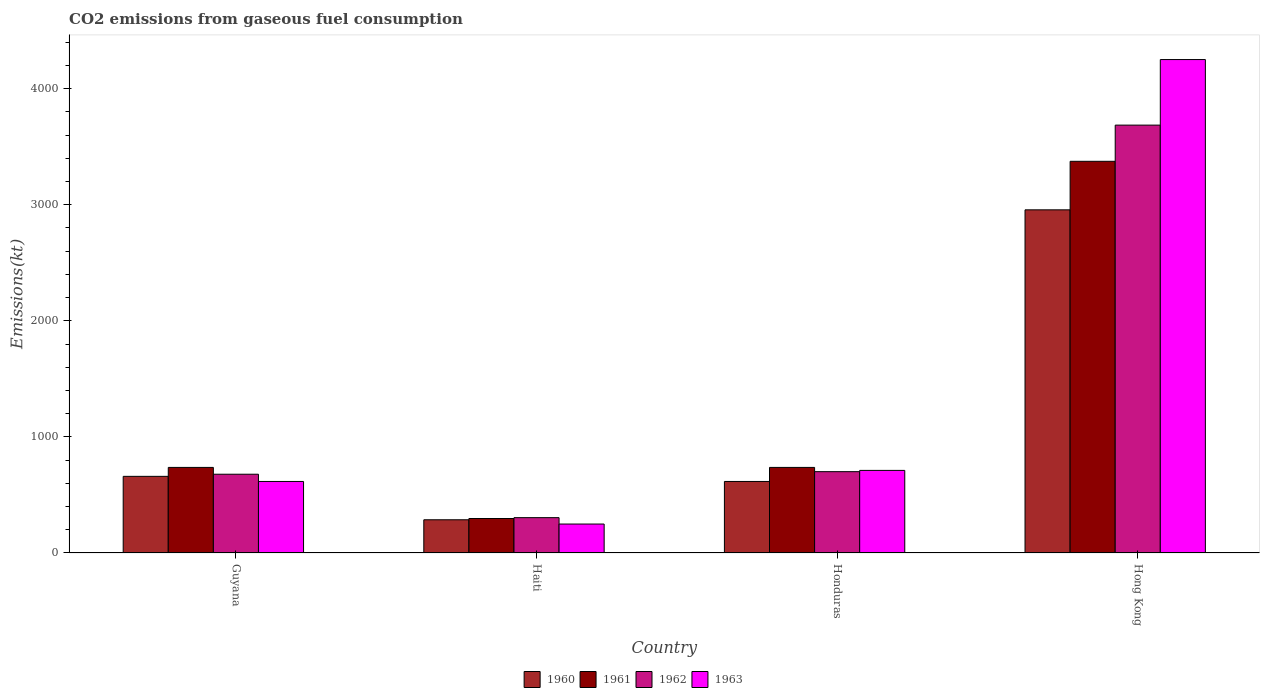Are the number of bars per tick equal to the number of legend labels?
Give a very brief answer. Yes. Are the number of bars on each tick of the X-axis equal?
Ensure brevity in your answer.  Yes. How many bars are there on the 1st tick from the left?
Provide a short and direct response. 4. What is the label of the 2nd group of bars from the left?
Your response must be concise. Haiti. What is the amount of CO2 emitted in 1960 in Haiti?
Give a very brief answer. 286.03. Across all countries, what is the maximum amount of CO2 emitted in 1960?
Provide a short and direct response. 2955.6. Across all countries, what is the minimum amount of CO2 emitted in 1963?
Provide a succinct answer. 249.36. In which country was the amount of CO2 emitted in 1962 maximum?
Offer a very short reply. Hong Kong. In which country was the amount of CO2 emitted in 1963 minimum?
Offer a very short reply. Haiti. What is the total amount of CO2 emitted in 1961 in the graph?
Keep it short and to the point. 5144.8. What is the difference between the amount of CO2 emitted in 1962 in Guyana and that in Honduras?
Your answer should be compact. -22. What is the difference between the amount of CO2 emitted in 1963 in Haiti and the amount of CO2 emitted in 1961 in Hong Kong?
Give a very brief answer. -3124.28. What is the average amount of CO2 emitted in 1963 per country?
Provide a succinct answer. 1456.72. What is the difference between the amount of CO2 emitted of/in 1963 and amount of CO2 emitted of/in 1960 in Hong Kong?
Provide a short and direct response. 1294.45. What is the ratio of the amount of CO2 emitted in 1963 in Haiti to that in Honduras?
Provide a short and direct response. 0.35. What is the difference between the highest and the second highest amount of CO2 emitted in 1960?
Offer a terse response. -2339.55. What is the difference between the highest and the lowest amount of CO2 emitted in 1963?
Ensure brevity in your answer.  4000.7. Is the sum of the amount of CO2 emitted in 1963 in Guyana and Haiti greater than the maximum amount of CO2 emitted in 1960 across all countries?
Provide a succinct answer. No. Is it the case that in every country, the sum of the amount of CO2 emitted in 1960 and amount of CO2 emitted in 1963 is greater than the sum of amount of CO2 emitted in 1961 and amount of CO2 emitted in 1962?
Your answer should be compact. No. How many bars are there?
Ensure brevity in your answer.  16. Are all the bars in the graph horizontal?
Keep it short and to the point. No. Where does the legend appear in the graph?
Offer a terse response. Bottom center. What is the title of the graph?
Make the answer very short. CO2 emissions from gaseous fuel consumption. What is the label or title of the Y-axis?
Your answer should be compact. Emissions(kt). What is the Emissions(kt) in 1960 in Guyana?
Keep it short and to the point. 660.06. What is the Emissions(kt) of 1961 in Guyana?
Provide a short and direct response. 737.07. What is the Emissions(kt) in 1962 in Guyana?
Give a very brief answer. 678.39. What is the Emissions(kt) in 1963 in Guyana?
Your response must be concise. 616.06. What is the Emissions(kt) of 1960 in Haiti?
Give a very brief answer. 286.03. What is the Emissions(kt) of 1961 in Haiti?
Provide a short and direct response. 297.03. What is the Emissions(kt) in 1962 in Haiti?
Make the answer very short. 304.36. What is the Emissions(kt) in 1963 in Haiti?
Give a very brief answer. 249.36. What is the Emissions(kt) of 1960 in Honduras?
Your response must be concise. 616.06. What is the Emissions(kt) in 1961 in Honduras?
Give a very brief answer. 737.07. What is the Emissions(kt) of 1962 in Honduras?
Offer a terse response. 700.4. What is the Emissions(kt) in 1963 in Honduras?
Offer a very short reply. 711.4. What is the Emissions(kt) of 1960 in Hong Kong?
Offer a terse response. 2955.6. What is the Emissions(kt) in 1961 in Hong Kong?
Your answer should be very brief. 3373.64. What is the Emissions(kt) of 1962 in Hong Kong?
Your answer should be very brief. 3685.34. What is the Emissions(kt) of 1963 in Hong Kong?
Provide a short and direct response. 4250.05. Across all countries, what is the maximum Emissions(kt) of 1960?
Your answer should be compact. 2955.6. Across all countries, what is the maximum Emissions(kt) in 1961?
Provide a short and direct response. 3373.64. Across all countries, what is the maximum Emissions(kt) of 1962?
Your answer should be very brief. 3685.34. Across all countries, what is the maximum Emissions(kt) of 1963?
Offer a terse response. 4250.05. Across all countries, what is the minimum Emissions(kt) of 1960?
Your answer should be compact. 286.03. Across all countries, what is the minimum Emissions(kt) in 1961?
Offer a very short reply. 297.03. Across all countries, what is the minimum Emissions(kt) in 1962?
Your answer should be very brief. 304.36. Across all countries, what is the minimum Emissions(kt) in 1963?
Your response must be concise. 249.36. What is the total Emissions(kt) of 1960 in the graph?
Offer a very short reply. 4517.74. What is the total Emissions(kt) of 1961 in the graph?
Give a very brief answer. 5144.8. What is the total Emissions(kt) in 1962 in the graph?
Offer a terse response. 5368.49. What is the total Emissions(kt) of 1963 in the graph?
Your response must be concise. 5826.86. What is the difference between the Emissions(kt) in 1960 in Guyana and that in Haiti?
Offer a terse response. 374.03. What is the difference between the Emissions(kt) of 1961 in Guyana and that in Haiti?
Make the answer very short. 440.04. What is the difference between the Emissions(kt) of 1962 in Guyana and that in Haiti?
Give a very brief answer. 374.03. What is the difference between the Emissions(kt) in 1963 in Guyana and that in Haiti?
Give a very brief answer. 366.7. What is the difference between the Emissions(kt) in 1960 in Guyana and that in Honduras?
Ensure brevity in your answer.  44. What is the difference between the Emissions(kt) of 1962 in Guyana and that in Honduras?
Your answer should be compact. -22. What is the difference between the Emissions(kt) of 1963 in Guyana and that in Honduras?
Keep it short and to the point. -95.34. What is the difference between the Emissions(kt) of 1960 in Guyana and that in Hong Kong?
Offer a terse response. -2295.54. What is the difference between the Emissions(kt) in 1961 in Guyana and that in Hong Kong?
Give a very brief answer. -2636.57. What is the difference between the Emissions(kt) of 1962 in Guyana and that in Hong Kong?
Give a very brief answer. -3006.94. What is the difference between the Emissions(kt) of 1963 in Guyana and that in Hong Kong?
Make the answer very short. -3634. What is the difference between the Emissions(kt) of 1960 in Haiti and that in Honduras?
Provide a succinct answer. -330.03. What is the difference between the Emissions(kt) of 1961 in Haiti and that in Honduras?
Your answer should be very brief. -440.04. What is the difference between the Emissions(kt) in 1962 in Haiti and that in Honduras?
Your answer should be compact. -396.04. What is the difference between the Emissions(kt) in 1963 in Haiti and that in Honduras?
Offer a very short reply. -462.04. What is the difference between the Emissions(kt) of 1960 in Haiti and that in Hong Kong?
Provide a short and direct response. -2669.58. What is the difference between the Emissions(kt) of 1961 in Haiti and that in Hong Kong?
Provide a short and direct response. -3076.61. What is the difference between the Emissions(kt) of 1962 in Haiti and that in Hong Kong?
Offer a very short reply. -3380.97. What is the difference between the Emissions(kt) of 1963 in Haiti and that in Hong Kong?
Your answer should be very brief. -4000.7. What is the difference between the Emissions(kt) of 1960 in Honduras and that in Hong Kong?
Keep it short and to the point. -2339.55. What is the difference between the Emissions(kt) in 1961 in Honduras and that in Hong Kong?
Make the answer very short. -2636.57. What is the difference between the Emissions(kt) in 1962 in Honduras and that in Hong Kong?
Give a very brief answer. -2984.94. What is the difference between the Emissions(kt) in 1963 in Honduras and that in Hong Kong?
Your response must be concise. -3538.66. What is the difference between the Emissions(kt) in 1960 in Guyana and the Emissions(kt) in 1961 in Haiti?
Your response must be concise. 363.03. What is the difference between the Emissions(kt) of 1960 in Guyana and the Emissions(kt) of 1962 in Haiti?
Provide a short and direct response. 355.7. What is the difference between the Emissions(kt) in 1960 in Guyana and the Emissions(kt) in 1963 in Haiti?
Ensure brevity in your answer.  410.7. What is the difference between the Emissions(kt) of 1961 in Guyana and the Emissions(kt) of 1962 in Haiti?
Offer a terse response. 432.71. What is the difference between the Emissions(kt) in 1961 in Guyana and the Emissions(kt) in 1963 in Haiti?
Make the answer very short. 487.71. What is the difference between the Emissions(kt) of 1962 in Guyana and the Emissions(kt) of 1963 in Haiti?
Your answer should be very brief. 429.04. What is the difference between the Emissions(kt) of 1960 in Guyana and the Emissions(kt) of 1961 in Honduras?
Your response must be concise. -77.01. What is the difference between the Emissions(kt) of 1960 in Guyana and the Emissions(kt) of 1962 in Honduras?
Your response must be concise. -40.34. What is the difference between the Emissions(kt) of 1960 in Guyana and the Emissions(kt) of 1963 in Honduras?
Offer a terse response. -51.34. What is the difference between the Emissions(kt) of 1961 in Guyana and the Emissions(kt) of 1962 in Honduras?
Your response must be concise. 36.67. What is the difference between the Emissions(kt) in 1961 in Guyana and the Emissions(kt) in 1963 in Honduras?
Offer a terse response. 25.67. What is the difference between the Emissions(kt) in 1962 in Guyana and the Emissions(kt) in 1963 in Honduras?
Your answer should be compact. -33. What is the difference between the Emissions(kt) in 1960 in Guyana and the Emissions(kt) in 1961 in Hong Kong?
Your response must be concise. -2713.58. What is the difference between the Emissions(kt) in 1960 in Guyana and the Emissions(kt) in 1962 in Hong Kong?
Ensure brevity in your answer.  -3025.28. What is the difference between the Emissions(kt) in 1960 in Guyana and the Emissions(kt) in 1963 in Hong Kong?
Provide a short and direct response. -3589.99. What is the difference between the Emissions(kt) of 1961 in Guyana and the Emissions(kt) of 1962 in Hong Kong?
Your answer should be compact. -2948.27. What is the difference between the Emissions(kt) of 1961 in Guyana and the Emissions(kt) of 1963 in Hong Kong?
Keep it short and to the point. -3512.99. What is the difference between the Emissions(kt) of 1962 in Guyana and the Emissions(kt) of 1963 in Hong Kong?
Give a very brief answer. -3571.66. What is the difference between the Emissions(kt) of 1960 in Haiti and the Emissions(kt) of 1961 in Honduras?
Offer a very short reply. -451.04. What is the difference between the Emissions(kt) of 1960 in Haiti and the Emissions(kt) of 1962 in Honduras?
Give a very brief answer. -414.37. What is the difference between the Emissions(kt) of 1960 in Haiti and the Emissions(kt) of 1963 in Honduras?
Give a very brief answer. -425.37. What is the difference between the Emissions(kt) of 1961 in Haiti and the Emissions(kt) of 1962 in Honduras?
Provide a succinct answer. -403.37. What is the difference between the Emissions(kt) in 1961 in Haiti and the Emissions(kt) in 1963 in Honduras?
Keep it short and to the point. -414.37. What is the difference between the Emissions(kt) of 1962 in Haiti and the Emissions(kt) of 1963 in Honduras?
Provide a succinct answer. -407.04. What is the difference between the Emissions(kt) in 1960 in Haiti and the Emissions(kt) in 1961 in Hong Kong?
Ensure brevity in your answer.  -3087.61. What is the difference between the Emissions(kt) of 1960 in Haiti and the Emissions(kt) of 1962 in Hong Kong?
Offer a very short reply. -3399.31. What is the difference between the Emissions(kt) of 1960 in Haiti and the Emissions(kt) of 1963 in Hong Kong?
Keep it short and to the point. -3964.03. What is the difference between the Emissions(kt) in 1961 in Haiti and the Emissions(kt) in 1962 in Hong Kong?
Make the answer very short. -3388.31. What is the difference between the Emissions(kt) of 1961 in Haiti and the Emissions(kt) of 1963 in Hong Kong?
Your answer should be very brief. -3953.03. What is the difference between the Emissions(kt) of 1962 in Haiti and the Emissions(kt) of 1963 in Hong Kong?
Your answer should be very brief. -3945.69. What is the difference between the Emissions(kt) of 1960 in Honduras and the Emissions(kt) of 1961 in Hong Kong?
Provide a short and direct response. -2757.58. What is the difference between the Emissions(kt) in 1960 in Honduras and the Emissions(kt) in 1962 in Hong Kong?
Provide a short and direct response. -3069.28. What is the difference between the Emissions(kt) in 1960 in Honduras and the Emissions(kt) in 1963 in Hong Kong?
Give a very brief answer. -3634. What is the difference between the Emissions(kt) in 1961 in Honduras and the Emissions(kt) in 1962 in Hong Kong?
Offer a terse response. -2948.27. What is the difference between the Emissions(kt) in 1961 in Honduras and the Emissions(kt) in 1963 in Hong Kong?
Keep it short and to the point. -3512.99. What is the difference between the Emissions(kt) in 1962 in Honduras and the Emissions(kt) in 1963 in Hong Kong?
Your answer should be compact. -3549.66. What is the average Emissions(kt) of 1960 per country?
Your response must be concise. 1129.44. What is the average Emissions(kt) in 1961 per country?
Offer a very short reply. 1286.2. What is the average Emissions(kt) of 1962 per country?
Make the answer very short. 1342.12. What is the average Emissions(kt) in 1963 per country?
Provide a short and direct response. 1456.72. What is the difference between the Emissions(kt) of 1960 and Emissions(kt) of 1961 in Guyana?
Provide a succinct answer. -77.01. What is the difference between the Emissions(kt) of 1960 and Emissions(kt) of 1962 in Guyana?
Make the answer very short. -18.34. What is the difference between the Emissions(kt) of 1960 and Emissions(kt) of 1963 in Guyana?
Give a very brief answer. 44. What is the difference between the Emissions(kt) in 1961 and Emissions(kt) in 1962 in Guyana?
Give a very brief answer. 58.67. What is the difference between the Emissions(kt) of 1961 and Emissions(kt) of 1963 in Guyana?
Give a very brief answer. 121.01. What is the difference between the Emissions(kt) of 1962 and Emissions(kt) of 1963 in Guyana?
Your answer should be very brief. 62.34. What is the difference between the Emissions(kt) of 1960 and Emissions(kt) of 1961 in Haiti?
Offer a terse response. -11. What is the difference between the Emissions(kt) in 1960 and Emissions(kt) in 1962 in Haiti?
Offer a very short reply. -18.34. What is the difference between the Emissions(kt) of 1960 and Emissions(kt) of 1963 in Haiti?
Your answer should be very brief. 36.67. What is the difference between the Emissions(kt) in 1961 and Emissions(kt) in 1962 in Haiti?
Offer a terse response. -7.33. What is the difference between the Emissions(kt) of 1961 and Emissions(kt) of 1963 in Haiti?
Provide a short and direct response. 47.67. What is the difference between the Emissions(kt) of 1962 and Emissions(kt) of 1963 in Haiti?
Offer a terse response. 55.01. What is the difference between the Emissions(kt) in 1960 and Emissions(kt) in 1961 in Honduras?
Give a very brief answer. -121.01. What is the difference between the Emissions(kt) of 1960 and Emissions(kt) of 1962 in Honduras?
Keep it short and to the point. -84.34. What is the difference between the Emissions(kt) in 1960 and Emissions(kt) in 1963 in Honduras?
Keep it short and to the point. -95.34. What is the difference between the Emissions(kt) in 1961 and Emissions(kt) in 1962 in Honduras?
Make the answer very short. 36.67. What is the difference between the Emissions(kt) of 1961 and Emissions(kt) of 1963 in Honduras?
Your answer should be very brief. 25.67. What is the difference between the Emissions(kt) of 1962 and Emissions(kt) of 1963 in Honduras?
Keep it short and to the point. -11. What is the difference between the Emissions(kt) of 1960 and Emissions(kt) of 1961 in Hong Kong?
Keep it short and to the point. -418.04. What is the difference between the Emissions(kt) in 1960 and Emissions(kt) in 1962 in Hong Kong?
Provide a succinct answer. -729.73. What is the difference between the Emissions(kt) in 1960 and Emissions(kt) in 1963 in Hong Kong?
Make the answer very short. -1294.45. What is the difference between the Emissions(kt) in 1961 and Emissions(kt) in 1962 in Hong Kong?
Give a very brief answer. -311.69. What is the difference between the Emissions(kt) in 1961 and Emissions(kt) in 1963 in Hong Kong?
Ensure brevity in your answer.  -876.41. What is the difference between the Emissions(kt) in 1962 and Emissions(kt) in 1963 in Hong Kong?
Provide a short and direct response. -564.72. What is the ratio of the Emissions(kt) in 1960 in Guyana to that in Haiti?
Your response must be concise. 2.31. What is the ratio of the Emissions(kt) in 1961 in Guyana to that in Haiti?
Offer a very short reply. 2.48. What is the ratio of the Emissions(kt) in 1962 in Guyana to that in Haiti?
Make the answer very short. 2.23. What is the ratio of the Emissions(kt) in 1963 in Guyana to that in Haiti?
Your answer should be very brief. 2.47. What is the ratio of the Emissions(kt) of 1960 in Guyana to that in Honduras?
Offer a terse response. 1.07. What is the ratio of the Emissions(kt) of 1961 in Guyana to that in Honduras?
Make the answer very short. 1. What is the ratio of the Emissions(kt) of 1962 in Guyana to that in Honduras?
Provide a short and direct response. 0.97. What is the ratio of the Emissions(kt) in 1963 in Guyana to that in Honduras?
Provide a short and direct response. 0.87. What is the ratio of the Emissions(kt) of 1960 in Guyana to that in Hong Kong?
Offer a terse response. 0.22. What is the ratio of the Emissions(kt) of 1961 in Guyana to that in Hong Kong?
Give a very brief answer. 0.22. What is the ratio of the Emissions(kt) of 1962 in Guyana to that in Hong Kong?
Your answer should be very brief. 0.18. What is the ratio of the Emissions(kt) of 1963 in Guyana to that in Hong Kong?
Provide a short and direct response. 0.14. What is the ratio of the Emissions(kt) of 1960 in Haiti to that in Honduras?
Provide a succinct answer. 0.46. What is the ratio of the Emissions(kt) of 1961 in Haiti to that in Honduras?
Provide a short and direct response. 0.4. What is the ratio of the Emissions(kt) in 1962 in Haiti to that in Honduras?
Keep it short and to the point. 0.43. What is the ratio of the Emissions(kt) of 1963 in Haiti to that in Honduras?
Your response must be concise. 0.35. What is the ratio of the Emissions(kt) of 1960 in Haiti to that in Hong Kong?
Make the answer very short. 0.1. What is the ratio of the Emissions(kt) of 1961 in Haiti to that in Hong Kong?
Your answer should be very brief. 0.09. What is the ratio of the Emissions(kt) of 1962 in Haiti to that in Hong Kong?
Offer a terse response. 0.08. What is the ratio of the Emissions(kt) of 1963 in Haiti to that in Hong Kong?
Your answer should be very brief. 0.06. What is the ratio of the Emissions(kt) of 1960 in Honduras to that in Hong Kong?
Make the answer very short. 0.21. What is the ratio of the Emissions(kt) in 1961 in Honduras to that in Hong Kong?
Provide a short and direct response. 0.22. What is the ratio of the Emissions(kt) in 1962 in Honduras to that in Hong Kong?
Provide a short and direct response. 0.19. What is the ratio of the Emissions(kt) of 1963 in Honduras to that in Hong Kong?
Offer a very short reply. 0.17. What is the difference between the highest and the second highest Emissions(kt) in 1960?
Your answer should be very brief. 2295.54. What is the difference between the highest and the second highest Emissions(kt) in 1961?
Your response must be concise. 2636.57. What is the difference between the highest and the second highest Emissions(kt) of 1962?
Your answer should be very brief. 2984.94. What is the difference between the highest and the second highest Emissions(kt) in 1963?
Ensure brevity in your answer.  3538.66. What is the difference between the highest and the lowest Emissions(kt) in 1960?
Your response must be concise. 2669.58. What is the difference between the highest and the lowest Emissions(kt) in 1961?
Make the answer very short. 3076.61. What is the difference between the highest and the lowest Emissions(kt) in 1962?
Offer a very short reply. 3380.97. What is the difference between the highest and the lowest Emissions(kt) of 1963?
Provide a succinct answer. 4000.7. 